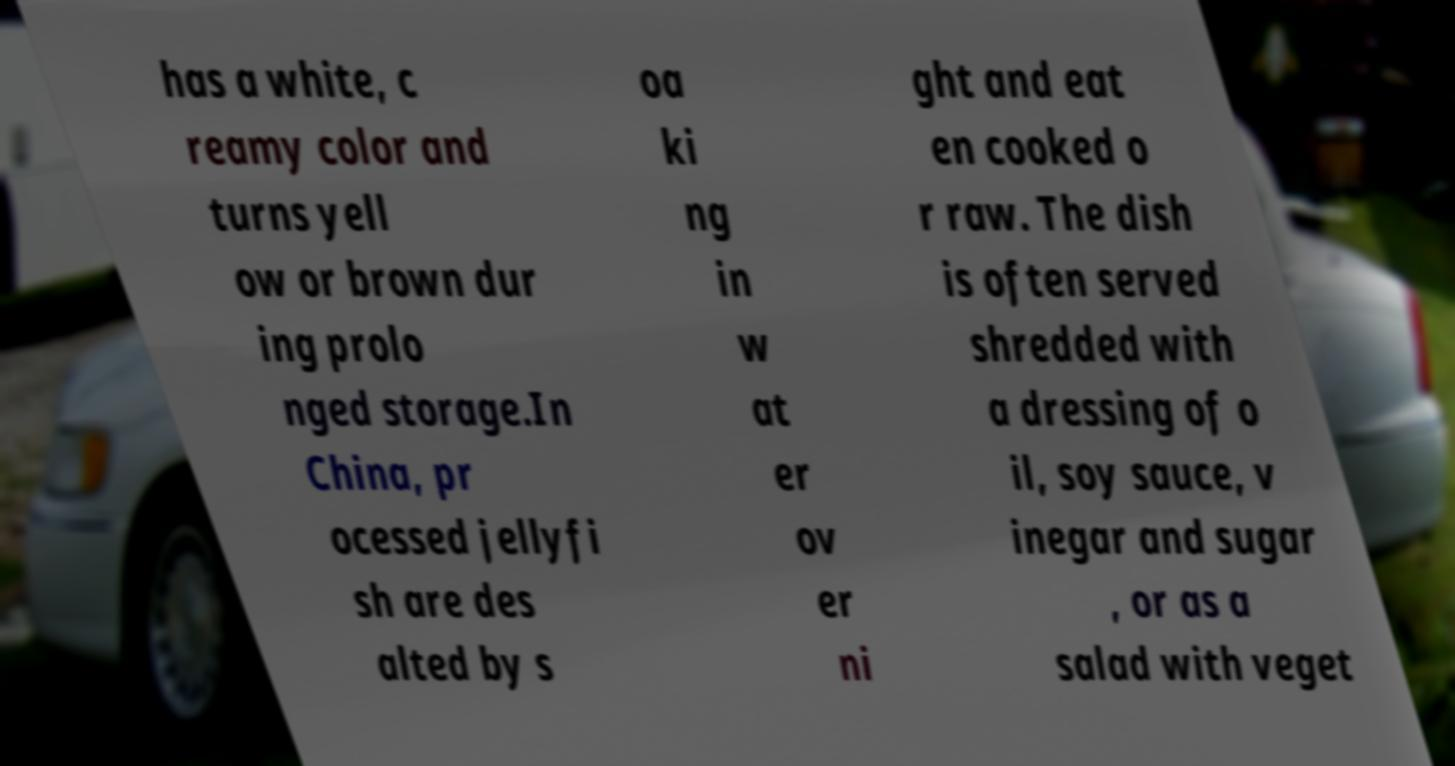What messages or text are displayed in this image? I need them in a readable, typed format. has a white, c reamy color and turns yell ow or brown dur ing prolo nged storage.In China, pr ocessed jellyfi sh are des alted by s oa ki ng in w at er ov er ni ght and eat en cooked o r raw. The dish is often served shredded with a dressing of o il, soy sauce, v inegar and sugar , or as a salad with veget 